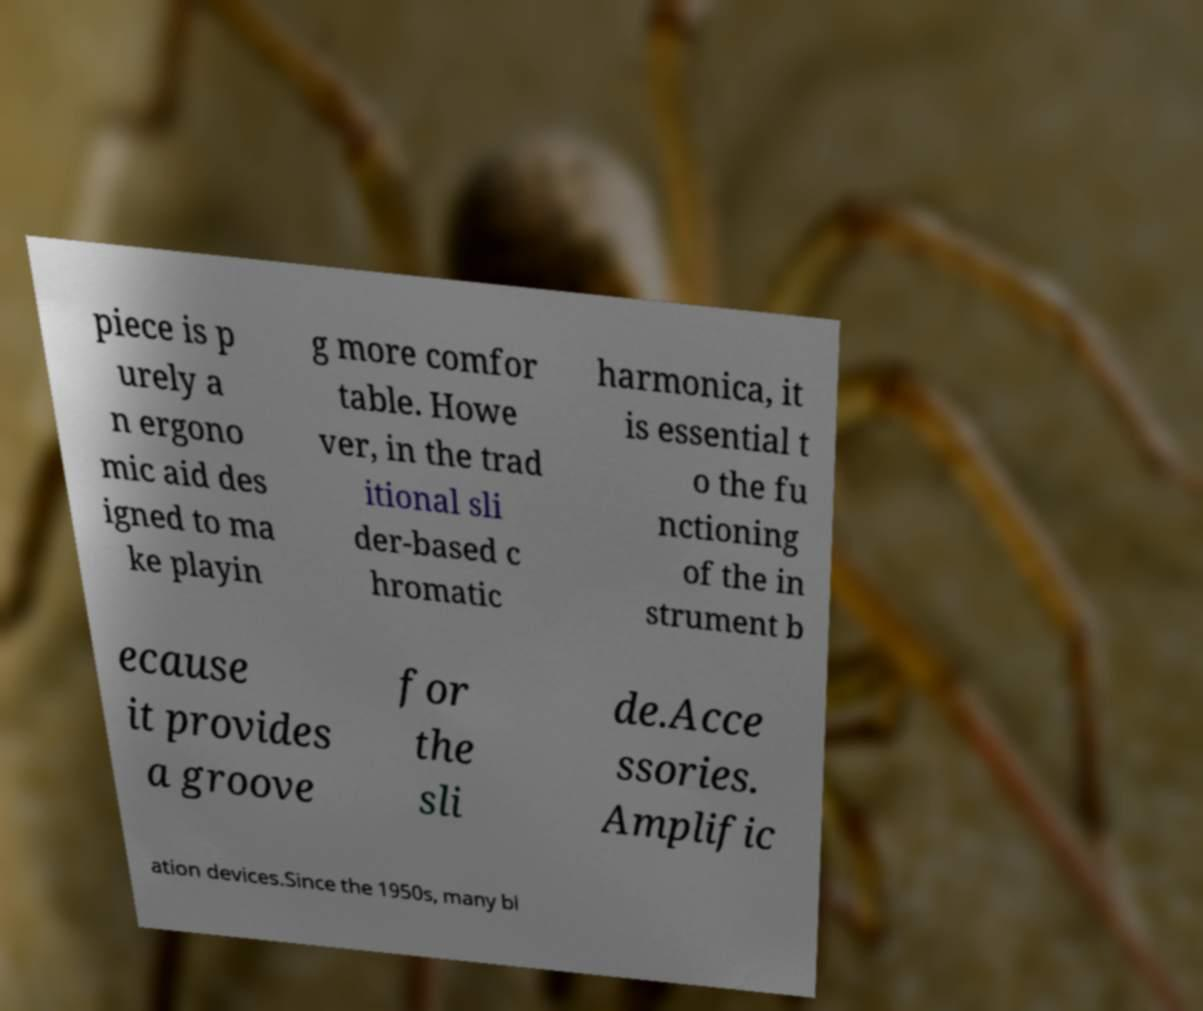Can you accurately transcribe the text from the provided image for me? piece is p urely a n ergono mic aid des igned to ma ke playin g more comfor table. Howe ver, in the trad itional sli der-based c hromatic harmonica, it is essential t o the fu nctioning of the in strument b ecause it provides a groove for the sli de.Acce ssories. Amplific ation devices.Since the 1950s, many bl 